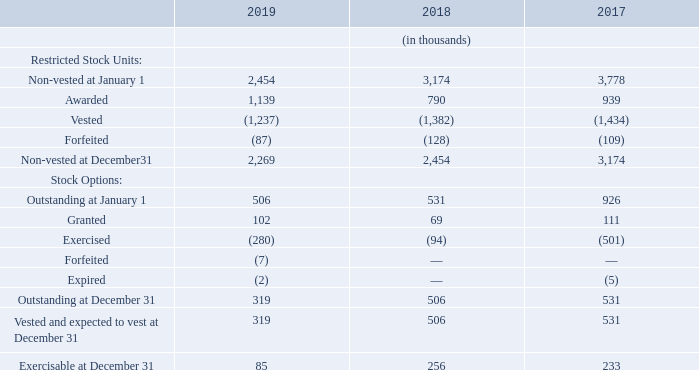Teradyne determined the stock options’ expected life based upon historical exercise data for executive officers, the age of the executive officers and the terms of the stock option grant. Volatility was determined using historical volatility for a period equal to the expected life. The risk-free interest rate was determined using the U.S. Treasury yield curve in effect at the time of grant. Dividend yield was based upon an estimated annual dividend amount of $0.36 per share divided by Teradyne’s stock price on the grant date of $37.95 for the 2019 grants, $47.70 for the 2018 grants and $28.56 for the 2017 grants.
Stock compensation plan activity for the years 2019, 2018, and 2017, is as follows:
How was the risk-free interest rate determined? Using the u.s. treasury yield curve in effect at the time of grant. How was volatility determined? Using historical volatility for a period equal to the expected life. In which years was the stock compensation plan activity recorded? 2019, 2018, 2017. In which year was the amount of Granted stocks the largest? 111>102>69
Answer: 2017. What was the change in granted stocks in 2019 from 2018?
Answer scale should be: thousand. 102-69
Answer: 33. What was the percentage change in granted stocks in 2019 from 2018?
Answer scale should be: percent. (102-69)/69
Answer: 47.83. 